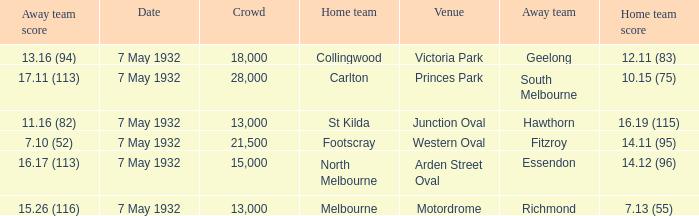Which home team has a Away team of hawthorn? St Kilda. 